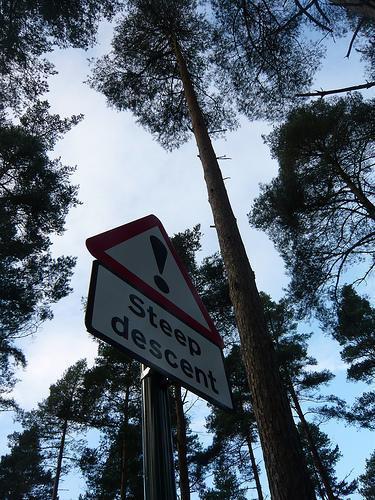How many signs are there?
Give a very brief answer. 2. 